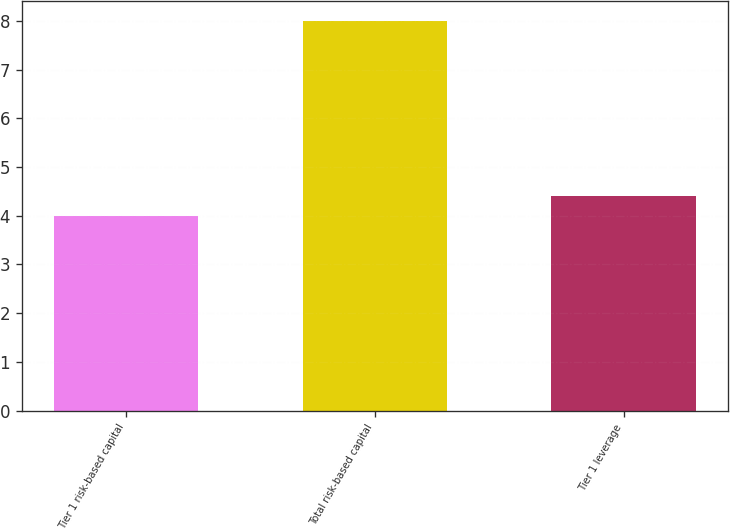Convert chart. <chart><loc_0><loc_0><loc_500><loc_500><bar_chart><fcel>Tier 1 risk-based capital<fcel>Total risk-based capital<fcel>Tier 1 leverage<nl><fcel>4<fcel>8<fcel>4.4<nl></chart> 